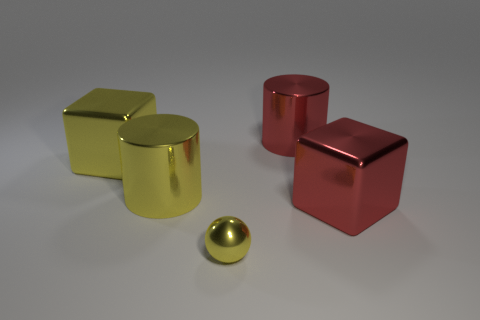Add 5 tiny cyan cubes. How many objects exist? 10 Subtract all cubes. How many objects are left? 3 Add 3 yellow cylinders. How many yellow cylinders exist? 4 Subtract 0 green spheres. How many objects are left? 5 Subtract all small yellow metallic objects. Subtract all tiny yellow balls. How many objects are left? 3 Add 1 cylinders. How many cylinders are left? 3 